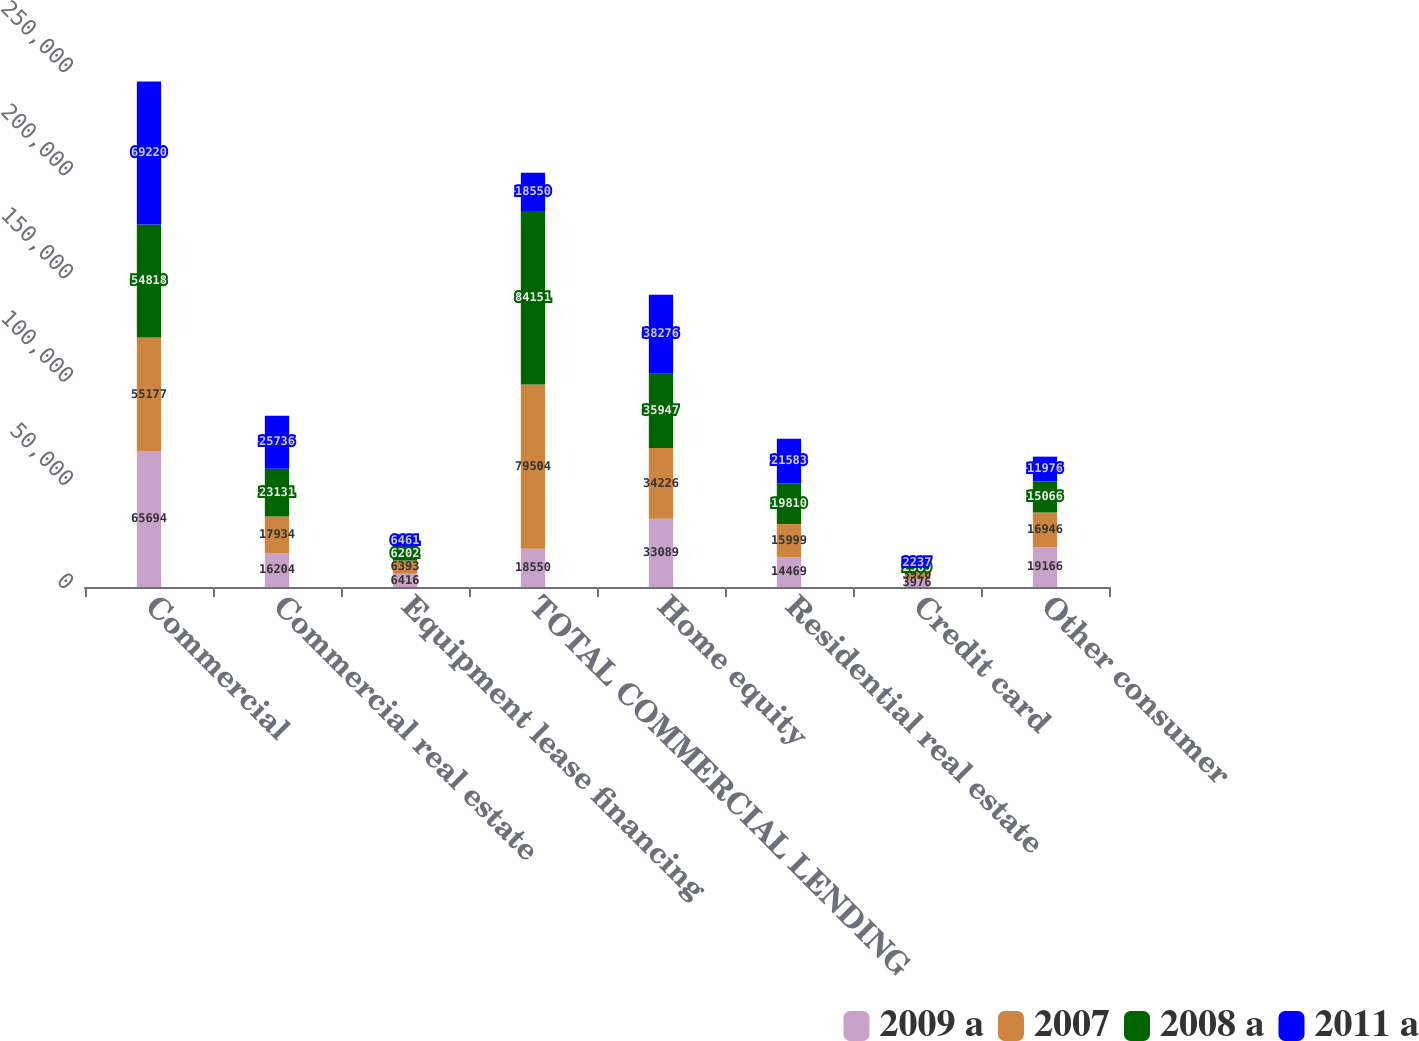<chart> <loc_0><loc_0><loc_500><loc_500><stacked_bar_chart><ecel><fcel>Commercial<fcel>Commercial real estate<fcel>Equipment lease financing<fcel>TOTAL COMMERCIAL LENDING<fcel>Home equity<fcel>Residential real estate<fcel>Credit card<fcel>Other consumer<nl><fcel>2009 a<fcel>65694<fcel>16204<fcel>6416<fcel>18550<fcel>33089<fcel>14469<fcel>3976<fcel>19166<nl><fcel>2007<fcel>55177<fcel>17934<fcel>6393<fcel>79504<fcel>34226<fcel>15999<fcel>3920<fcel>16946<nl><fcel>2008 a<fcel>54818<fcel>23131<fcel>6202<fcel>84151<fcel>35947<fcel>19810<fcel>2569<fcel>15066<nl><fcel>2011 a<fcel>69220<fcel>25736<fcel>6461<fcel>18550<fcel>38276<fcel>21583<fcel>2237<fcel>11976<nl></chart> 